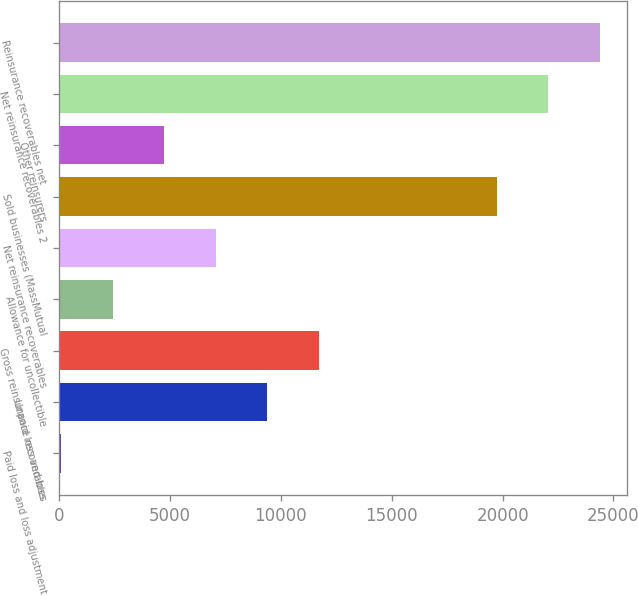Convert chart to OTSL. <chart><loc_0><loc_0><loc_500><loc_500><bar_chart><fcel>Paid loss and loss adjustment<fcel>Unpaid loss and loss<fcel>Gross reinsurance recoverables<fcel>Allowance for uncollectible<fcel>Net reinsurance recoverables<fcel>Sold businesses (MassMutual<fcel>Other reinsurers<fcel>Net reinsurance recoverables 2<fcel>Reinsurance recoverables net<nl><fcel>89<fcel>9377.8<fcel>11700<fcel>2411.2<fcel>7055.6<fcel>19729<fcel>4733.4<fcel>22051.2<fcel>24373.4<nl></chart> 